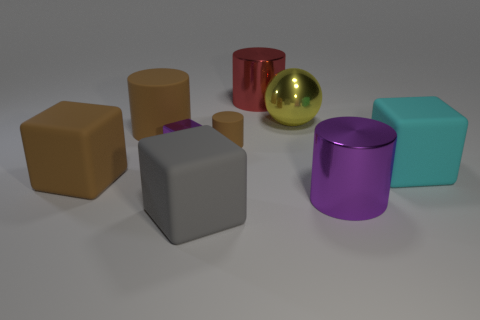There is a large cylinder right of the red cylinder; is it the same color as the tiny metal cube?
Provide a succinct answer. Yes. Do the object in front of the purple shiny cylinder and the purple shiny cube have the same size?
Your answer should be compact. No. The big rubber object that is the same color as the large matte cylinder is what shape?
Keep it short and to the point. Cube. What number of purple cylinders have the same material as the tiny purple thing?
Your response must be concise. 1. The purple thing in front of the cyan thing that is in front of the large metal cylinder that is to the left of the large purple metal cylinder is made of what material?
Give a very brief answer. Metal. There is a metallic cylinder that is in front of the big cube right of the purple metallic cylinder; what color is it?
Offer a terse response. Purple. What is the color of the shiny ball that is the same size as the red thing?
Provide a short and direct response. Yellow. How many small things are balls or metal objects?
Give a very brief answer. 1. Are there more big rubber things that are on the left side of the purple cylinder than balls that are in front of the big gray rubber object?
Your answer should be compact. Yes. There is another rubber cylinder that is the same color as the big matte cylinder; what is its size?
Your answer should be compact. Small. 